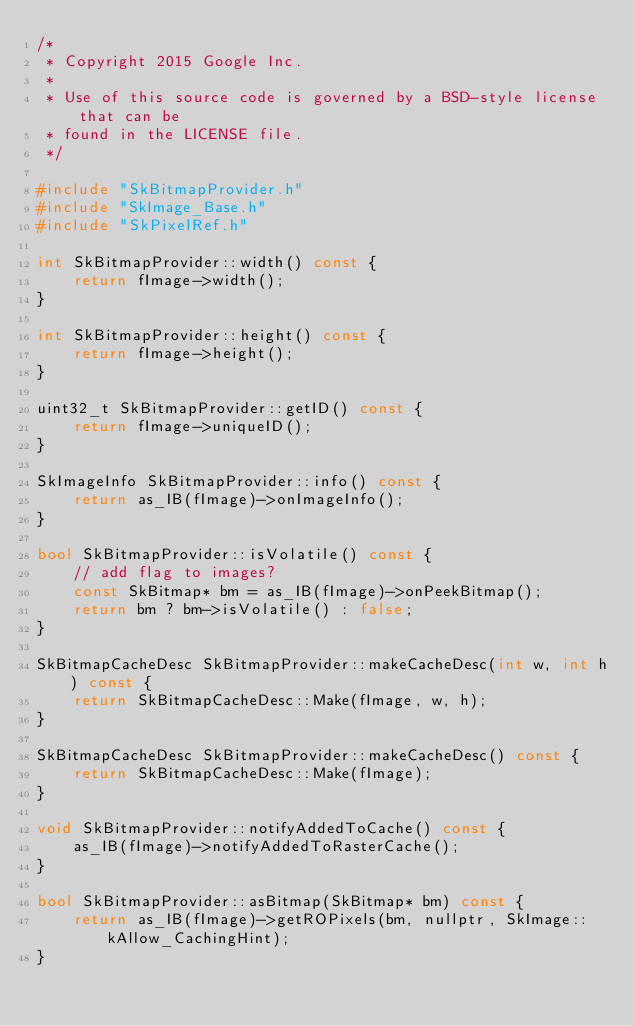<code> <loc_0><loc_0><loc_500><loc_500><_C++_>/*
 * Copyright 2015 Google Inc.
 *
 * Use of this source code is governed by a BSD-style license that can be
 * found in the LICENSE file.
 */

#include "SkBitmapProvider.h"
#include "SkImage_Base.h"
#include "SkPixelRef.h"

int SkBitmapProvider::width() const {
    return fImage->width();
}

int SkBitmapProvider::height() const {
    return fImage->height();
}

uint32_t SkBitmapProvider::getID() const {
    return fImage->uniqueID();
}

SkImageInfo SkBitmapProvider::info() const {
    return as_IB(fImage)->onImageInfo();
}

bool SkBitmapProvider::isVolatile() const {
    // add flag to images?
    const SkBitmap* bm = as_IB(fImage)->onPeekBitmap();
    return bm ? bm->isVolatile() : false;
}

SkBitmapCacheDesc SkBitmapProvider::makeCacheDesc(int w, int h) const {
    return SkBitmapCacheDesc::Make(fImage, w, h);
}

SkBitmapCacheDesc SkBitmapProvider::makeCacheDesc() const {
    return SkBitmapCacheDesc::Make(fImage);
}

void SkBitmapProvider::notifyAddedToCache() const {
    as_IB(fImage)->notifyAddedToRasterCache();
}

bool SkBitmapProvider::asBitmap(SkBitmap* bm) const {
    return as_IB(fImage)->getROPixels(bm, nullptr, SkImage::kAllow_CachingHint);
}
</code> 